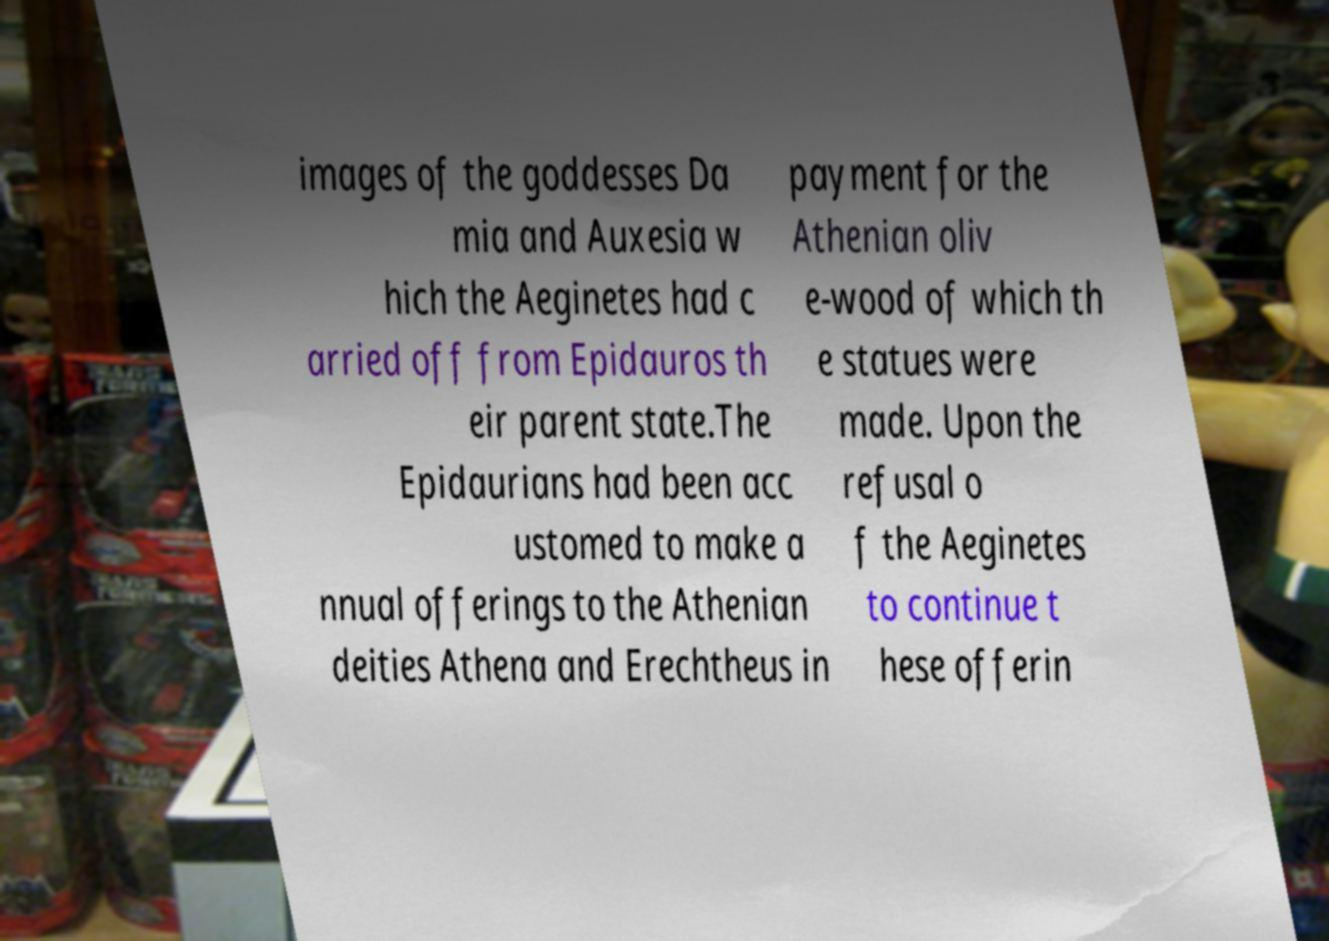Please read and relay the text visible in this image. What does it say? images of the goddesses Da mia and Auxesia w hich the Aeginetes had c arried off from Epidauros th eir parent state.The Epidaurians had been acc ustomed to make a nnual offerings to the Athenian deities Athena and Erechtheus in payment for the Athenian oliv e-wood of which th e statues were made. Upon the refusal o f the Aeginetes to continue t hese offerin 